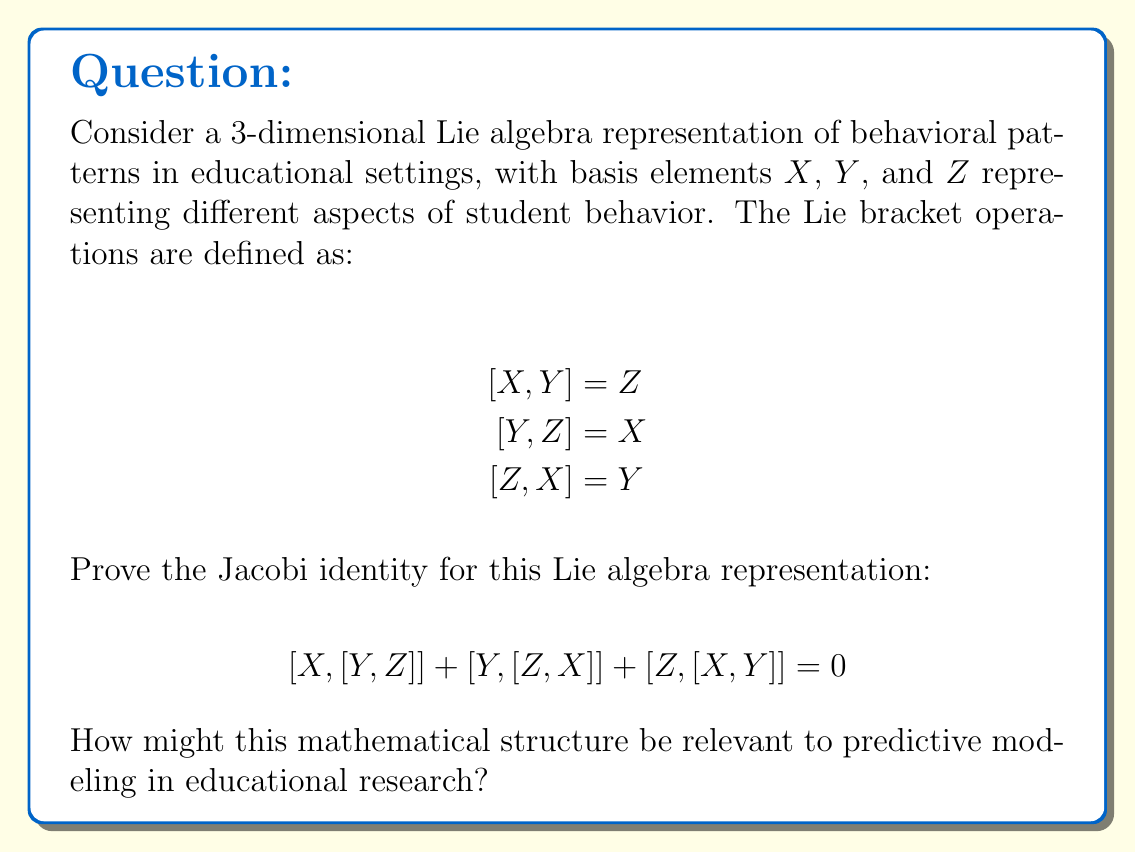Teach me how to tackle this problem. To prove the Jacobi identity for this Lie algebra representation, we need to evaluate each term of the equation and show that their sum is zero. Let's break it down step by step:

1) First term: $[X,[Y,Z]]$
   We know that $[Y,Z] = X$, so:
   $[X,[Y,Z]] = [X,X] = 0$ (since the Lie bracket of any element with itself is always zero)

2) Second term: $[Y,[Z,X]]$
   We know that $[Z,X] = Y$, so:
   $[Y,[Z,X]] = [Y,Y] = 0$

3) Third term: $[Z,[X,Y]]$
   We know that $[X,Y] = Z$, so:
   $[Z,[X,Y]] = [Z,Z] = 0$

4) Now, we add all three terms:
   $[X,[Y,Z]] + [Y,[Z,X]] + [Z,[X,Y]] = 0 + 0 + 0 = 0$

Thus, we have proven that the Jacobi identity holds for this Lie algebra representation.

Relevance to predictive modeling in educational research:

This mathematical structure could be relevant to predictive modeling in educational settings in several ways:

1) The three basis elements (X, Y, Z) could represent different aspects of student behavior or performance that interact with each other in complex ways.

2) The Lie bracket operations could model how changes in one aspect of behavior influence changes in another, capturing non-linear relationships between variables.

3) The Jacobi identity ensures consistency in these interactions, which is crucial for building reliable predictive models.

4) This algebraic structure could help in developing more sophisticated models that capture the dynamic and interconnected nature of behavioral patterns in educational contexts.

5) Understanding such mathematical structures could lead to new insights in how to represent and analyze complex behavioral data in educational research.
Answer: The Jacobi identity is proven for the given Lie algebra representation:

$$[X,[Y,Z]] + [Y,[Z,X]] + [Z,[X,Y]] = 0 + 0 + 0 = 0$$

This mathematical structure could be relevant to predictive modeling in educational research by providing a framework for representing complex, interrelated behavioral variables and their dynamic interactions in a consistent and mathematically rigorous manner. 